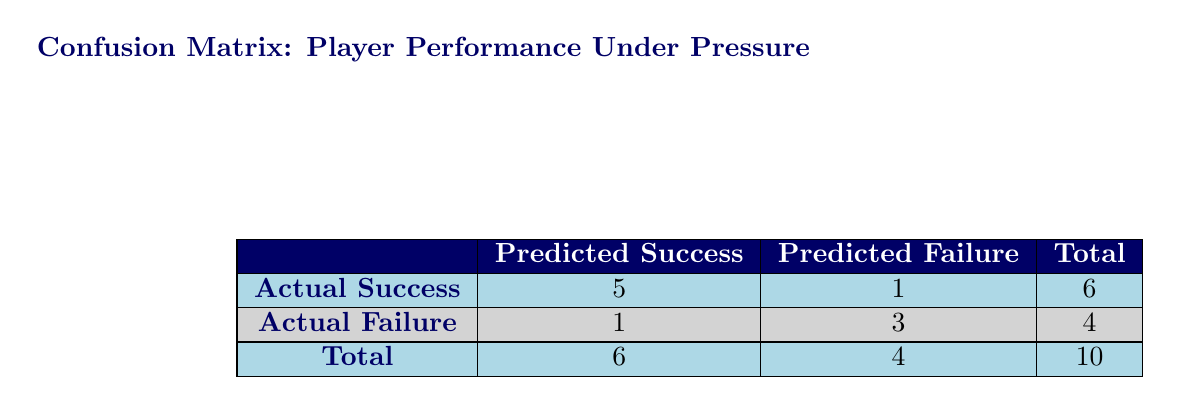What is the total number of players assessed? The total number of players can be found in the last row and last column of the table, which shows a total of 10 players.
Answer: 10 How many players were successful under pressure? To find the number of players who succeeded under pressure, look at the "Actual Success" row under "Predicted Success," which shows a value of 5.
Answer: 5 What is the number of players predicted to fail that actually succeeded? Refer to the "Actual Success" row in the "Predicted Failure" column, which indicates there is 1 player who was predicted to fail but actually succeeded.
Answer: 1 What percentage of players succeeded under pressure? To find the percentage, divide the number of players who succeeded (5) by the total number of players (10) and multiply by 100. The calculation is (5/10) * 100 = 50%.
Answer: 50% Was there any player predicted to succeed that actually failed? Yes, there is 1 player predicted to succeed but actually failed, which can be seen in the "Actual Failure" row under the "Predicted Success" column.
Answer: Yes How many players failed under pressure? From the "Total" row in the "Actual Failure" section, we see a total of 4 players who failed under pressure.
Answer: 4 What is the ratio of players successfully handling pressure to those who failed? The ratio is determined by the number of successful players (5) to the number of players who failed (4). So, the ratio is 5:4.
Answer: 5:4 Which group had more successes: players with high match importance or those with medium importance? Players with high match importance had 5 successes, while medium importance players had 3 successes. Since 5 is greater than 3, high match importance had more successes.
Answer: High importance If a player was predicted to fail, what is the probability they actually succeeded? There is 1 player who was predicted to fail that succeeded (1 actual success from predicted failures), and there are 4 total players predicted to fail. Therefore, the probability is 1 out of 4, or 25%.
Answer: 25% 